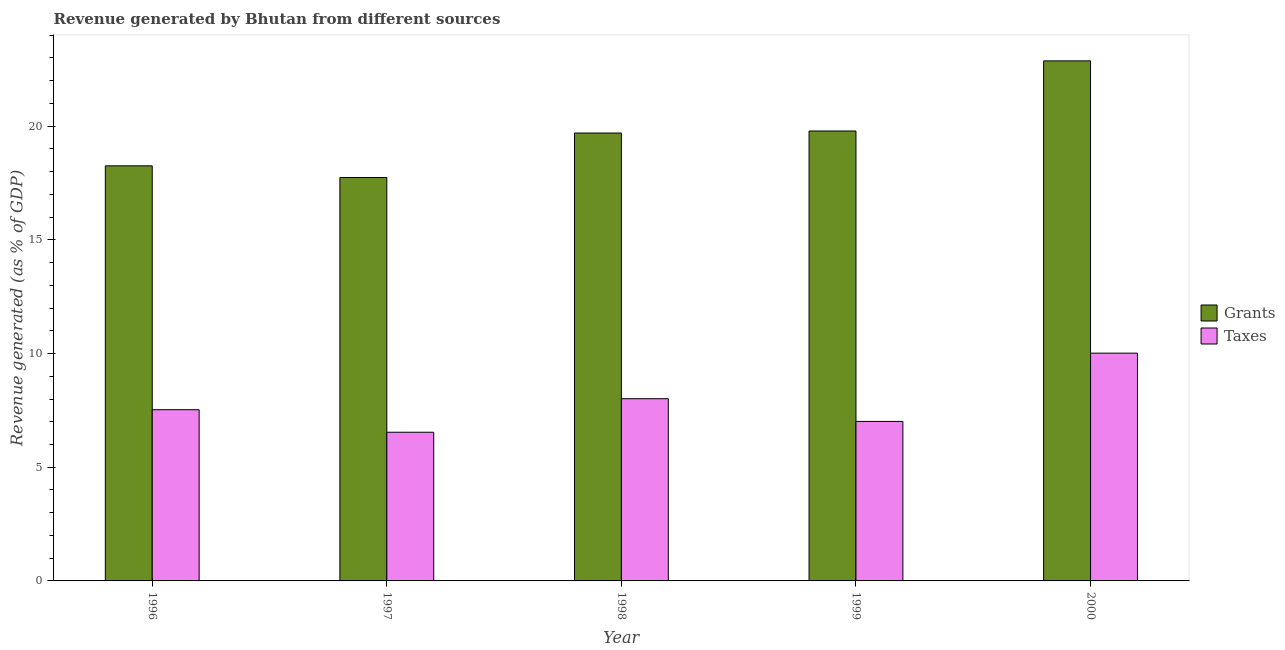How many groups of bars are there?
Offer a terse response. 5. Are the number of bars per tick equal to the number of legend labels?
Offer a terse response. Yes. What is the label of the 2nd group of bars from the left?
Your answer should be compact. 1997. In how many cases, is the number of bars for a given year not equal to the number of legend labels?
Ensure brevity in your answer.  0. What is the revenue generated by taxes in 2000?
Your response must be concise. 10.02. Across all years, what is the maximum revenue generated by taxes?
Offer a very short reply. 10.02. Across all years, what is the minimum revenue generated by grants?
Your response must be concise. 17.74. In which year was the revenue generated by taxes maximum?
Your answer should be very brief. 2000. In which year was the revenue generated by grants minimum?
Ensure brevity in your answer.  1997. What is the total revenue generated by taxes in the graph?
Keep it short and to the point. 39.12. What is the difference between the revenue generated by grants in 1996 and that in 1999?
Ensure brevity in your answer.  -1.53. What is the difference between the revenue generated by taxes in 2000 and the revenue generated by grants in 1996?
Give a very brief answer. 2.49. What is the average revenue generated by grants per year?
Provide a short and direct response. 19.67. In the year 1997, what is the difference between the revenue generated by grants and revenue generated by taxes?
Keep it short and to the point. 0. In how many years, is the revenue generated by grants greater than 9 %?
Ensure brevity in your answer.  5. What is the ratio of the revenue generated by grants in 1998 to that in 2000?
Keep it short and to the point. 0.86. Is the revenue generated by taxes in 1997 less than that in 2000?
Your answer should be compact. Yes. What is the difference between the highest and the second highest revenue generated by grants?
Your answer should be very brief. 3.08. What is the difference between the highest and the lowest revenue generated by grants?
Offer a terse response. 5.13. In how many years, is the revenue generated by grants greater than the average revenue generated by grants taken over all years?
Offer a terse response. 3. What does the 1st bar from the left in 1996 represents?
Make the answer very short. Grants. What does the 2nd bar from the right in 1998 represents?
Your answer should be compact. Grants. What is the difference between two consecutive major ticks on the Y-axis?
Make the answer very short. 5. Does the graph contain any zero values?
Make the answer very short. No. What is the title of the graph?
Give a very brief answer. Revenue generated by Bhutan from different sources. Does "Fraud firms" appear as one of the legend labels in the graph?
Provide a short and direct response. No. What is the label or title of the X-axis?
Your answer should be compact. Year. What is the label or title of the Y-axis?
Give a very brief answer. Revenue generated (as % of GDP). What is the Revenue generated (as % of GDP) in Grants in 1996?
Offer a very short reply. 18.26. What is the Revenue generated (as % of GDP) in Taxes in 1996?
Give a very brief answer. 7.53. What is the Revenue generated (as % of GDP) of Grants in 1997?
Ensure brevity in your answer.  17.74. What is the Revenue generated (as % of GDP) of Taxes in 1997?
Your answer should be very brief. 6.54. What is the Revenue generated (as % of GDP) of Grants in 1998?
Provide a succinct answer. 19.7. What is the Revenue generated (as % of GDP) of Taxes in 1998?
Give a very brief answer. 8.01. What is the Revenue generated (as % of GDP) in Grants in 1999?
Offer a terse response. 19.79. What is the Revenue generated (as % of GDP) of Taxes in 1999?
Your answer should be very brief. 7.02. What is the Revenue generated (as % of GDP) in Grants in 2000?
Your response must be concise. 22.87. What is the Revenue generated (as % of GDP) of Taxes in 2000?
Keep it short and to the point. 10.02. Across all years, what is the maximum Revenue generated (as % of GDP) in Grants?
Your response must be concise. 22.87. Across all years, what is the maximum Revenue generated (as % of GDP) of Taxes?
Your response must be concise. 10.02. Across all years, what is the minimum Revenue generated (as % of GDP) of Grants?
Offer a very short reply. 17.74. Across all years, what is the minimum Revenue generated (as % of GDP) of Taxes?
Keep it short and to the point. 6.54. What is the total Revenue generated (as % of GDP) in Grants in the graph?
Make the answer very short. 98.36. What is the total Revenue generated (as % of GDP) in Taxes in the graph?
Your answer should be compact. 39.12. What is the difference between the Revenue generated (as % of GDP) in Grants in 1996 and that in 1997?
Your response must be concise. 0.51. What is the difference between the Revenue generated (as % of GDP) of Grants in 1996 and that in 1998?
Your response must be concise. -1.44. What is the difference between the Revenue generated (as % of GDP) of Taxes in 1996 and that in 1998?
Make the answer very short. -0.48. What is the difference between the Revenue generated (as % of GDP) of Grants in 1996 and that in 1999?
Provide a short and direct response. -1.53. What is the difference between the Revenue generated (as % of GDP) in Taxes in 1996 and that in 1999?
Your answer should be compact. 0.52. What is the difference between the Revenue generated (as % of GDP) in Grants in 1996 and that in 2000?
Offer a terse response. -4.62. What is the difference between the Revenue generated (as % of GDP) of Taxes in 1996 and that in 2000?
Your answer should be compact. -2.49. What is the difference between the Revenue generated (as % of GDP) in Grants in 1997 and that in 1998?
Your answer should be very brief. -1.96. What is the difference between the Revenue generated (as % of GDP) in Taxes in 1997 and that in 1998?
Offer a very short reply. -1.47. What is the difference between the Revenue generated (as % of GDP) in Grants in 1997 and that in 1999?
Your answer should be very brief. -2.05. What is the difference between the Revenue generated (as % of GDP) of Taxes in 1997 and that in 1999?
Provide a succinct answer. -0.48. What is the difference between the Revenue generated (as % of GDP) in Grants in 1997 and that in 2000?
Make the answer very short. -5.13. What is the difference between the Revenue generated (as % of GDP) of Taxes in 1997 and that in 2000?
Your response must be concise. -3.48. What is the difference between the Revenue generated (as % of GDP) of Grants in 1998 and that in 1999?
Ensure brevity in your answer.  -0.09. What is the difference between the Revenue generated (as % of GDP) of Grants in 1998 and that in 2000?
Your answer should be very brief. -3.17. What is the difference between the Revenue generated (as % of GDP) of Taxes in 1998 and that in 2000?
Keep it short and to the point. -2. What is the difference between the Revenue generated (as % of GDP) of Grants in 1999 and that in 2000?
Give a very brief answer. -3.08. What is the difference between the Revenue generated (as % of GDP) in Taxes in 1999 and that in 2000?
Offer a very short reply. -3. What is the difference between the Revenue generated (as % of GDP) of Grants in 1996 and the Revenue generated (as % of GDP) of Taxes in 1997?
Make the answer very short. 11.72. What is the difference between the Revenue generated (as % of GDP) in Grants in 1996 and the Revenue generated (as % of GDP) in Taxes in 1998?
Provide a short and direct response. 10.24. What is the difference between the Revenue generated (as % of GDP) of Grants in 1996 and the Revenue generated (as % of GDP) of Taxes in 1999?
Your answer should be very brief. 11.24. What is the difference between the Revenue generated (as % of GDP) in Grants in 1996 and the Revenue generated (as % of GDP) in Taxes in 2000?
Your response must be concise. 8.24. What is the difference between the Revenue generated (as % of GDP) of Grants in 1997 and the Revenue generated (as % of GDP) of Taxes in 1998?
Keep it short and to the point. 9.73. What is the difference between the Revenue generated (as % of GDP) in Grants in 1997 and the Revenue generated (as % of GDP) in Taxes in 1999?
Keep it short and to the point. 10.73. What is the difference between the Revenue generated (as % of GDP) of Grants in 1997 and the Revenue generated (as % of GDP) of Taxes in 2000?
Ensure brevity in your answer.  7.72. What is the difference between the Revenue generated (as % of GDP) in Grants in 1998 and the Revenue generated (as % of GDP) in Taxes in 1999?
Your answer should be compact. 12.68. What is the difference between the Revenue generated (as % of GDP) in Grants in 1998 and the Revenue generated (as % of GDP) in Taxes in 2000?
Keep it short and to the point. 9.68. What is the difference between the Revenue generated (as % of GDP) of Grants in 1999 and the Revenue generated (as % of GDP) of Taxes in 2000?
Ensure brevity in your answer.  9.77. What is the average Revenue generated (as % of GDP) of Grants per year?
Offer a very short reply. 19.67. What is the average Revenue generated (as % of GDP) in Taxes per year?
Provide a succinct answer. 7.82. In the year 1996, what is the difference between the Revenue generated (as % of GDP) of Grants and Revenue generated (as % of GDP) of Taxes?
Keep it short and to the point. 10.73. In the year 1997, what is the difference between the Revenue generated (as % of GDP) in Grants and Revenue generated (as % of GDP) in Taxes?
Keep it short and to the point. 11.2. In the year 1998, what is the difference between the Revenue generated (as % of GDP) of Grants and Revenue generated (as % of GDP) of Taxes?
Give a very brief answer. 11.69. In the year 1999, what is the difference between the Revenue generated (as % of GDP) of Grants and Revenue generated (as % of GDP) of Taxes?
Make the answer very short. 12.77. In the year 2000, what is the difference between the Revenue generated (as % of GDP) of Grants and Revenue generated (as % of GDP) of Taxes?
Provide a succinct answer. 12.85. What is the ratio of the Revenue generated (as % of GDP) in Taxes in 1996 to that in 1997?
Offer a very short reply. 1.15. What is the ratio of the Revenue generated (as % of GDP) in Grants in 1996 to that in 1998?
Give a very brief answer. 0.93. What is the ratio of the Revenue generated (as % of GDP) of Taxes in 1996 to that in 1998?
Provide a short and direct response. 0.94. What is the ratio of the Revenue generated (as % of GDP) of Grants in 1996 to that in 1999?
Your response must be concise. 0.92. What is the ratio of the Revenue generated (as % of GDP) in Taxes in 1996 to that in 1999?
Keep it short and to the point. 1.07. What is the ratio of the Revenue generated (as % of GDP) in Grants in 1996 to that in 2000?
Offer a very short reply. 0.8. What is the ratio of the Revenue generated (as % of GDP) of Taxes in 1996 to that in 2000?
Offer a very short reply. 0.75. What is the ratio of the Revenue generated (as % of GDP) of Grants in 1997 to that in 1998?
Make the answer very short. 0.9. What is the ratio of the Revenue generated (as % of GDP) of Taxes in 1997 to that in 1998?
Your response must be concise. 0.82. What is the ratio of the Revenue generated (as % of GDP) in Grants in 1997 to that in 1999?
Keep it short and to the point. 0.9. What is the ratio of the Revenue generated (as % of GDP) in Taxes in 1997 to that in 1999?
Your answer should be compact. 0.93. What is the ratio of the Revenue generated (as % of GDP) of Grants in 1997 to that in 2000?
Your answer should be very brief. 0.78. What is the ratio of the Revenue generated (as % of GDP) in Taxes in 1997 to that in 2000?
Your answer should be compact. 0.65. What is the ratio of the Revenue generated (as % of GDP) in Taxes in 1998 to that in 1999?
Offer a terse response. 1.14. What is the ratio of the Revenue generated (as % of GDP) of Grants in 1998 to that in 2000?
Ensure brevity in your answer.  0.86. What is the ratio of the Revenue generated (as % of GDP) of Taxes in 1998 to that in 2000?
Offer a terse response. 0.8. What is the ratio of the Revenue generated (as % of GDP) of Grants in 1999 to that in 2000?
Make the answer very short. 0.87. What is the ratio of the Revenue generated (as % of GDP) of Taxes in 1999 to that in 2000?
Your answer should be very brief. 0.7. What is the difference between the highest and the second highest Revenue generated (as % of GDP) in Grants?
Make the answer very short. 3.08. What is the difference between the highest and the second highest Revenue generated (as % of GDP) in Taxes?
Offer a very short reply. 2. What is the difference between the highest and the lowest Revenue generated (as % of GDP) of Grants?
Ensure brevity in your answer.  5.13. What is the difference between the highest and the lowest Revenue generated (as % of GDP) in Taxes?
Make the answer very short. 3.48. 